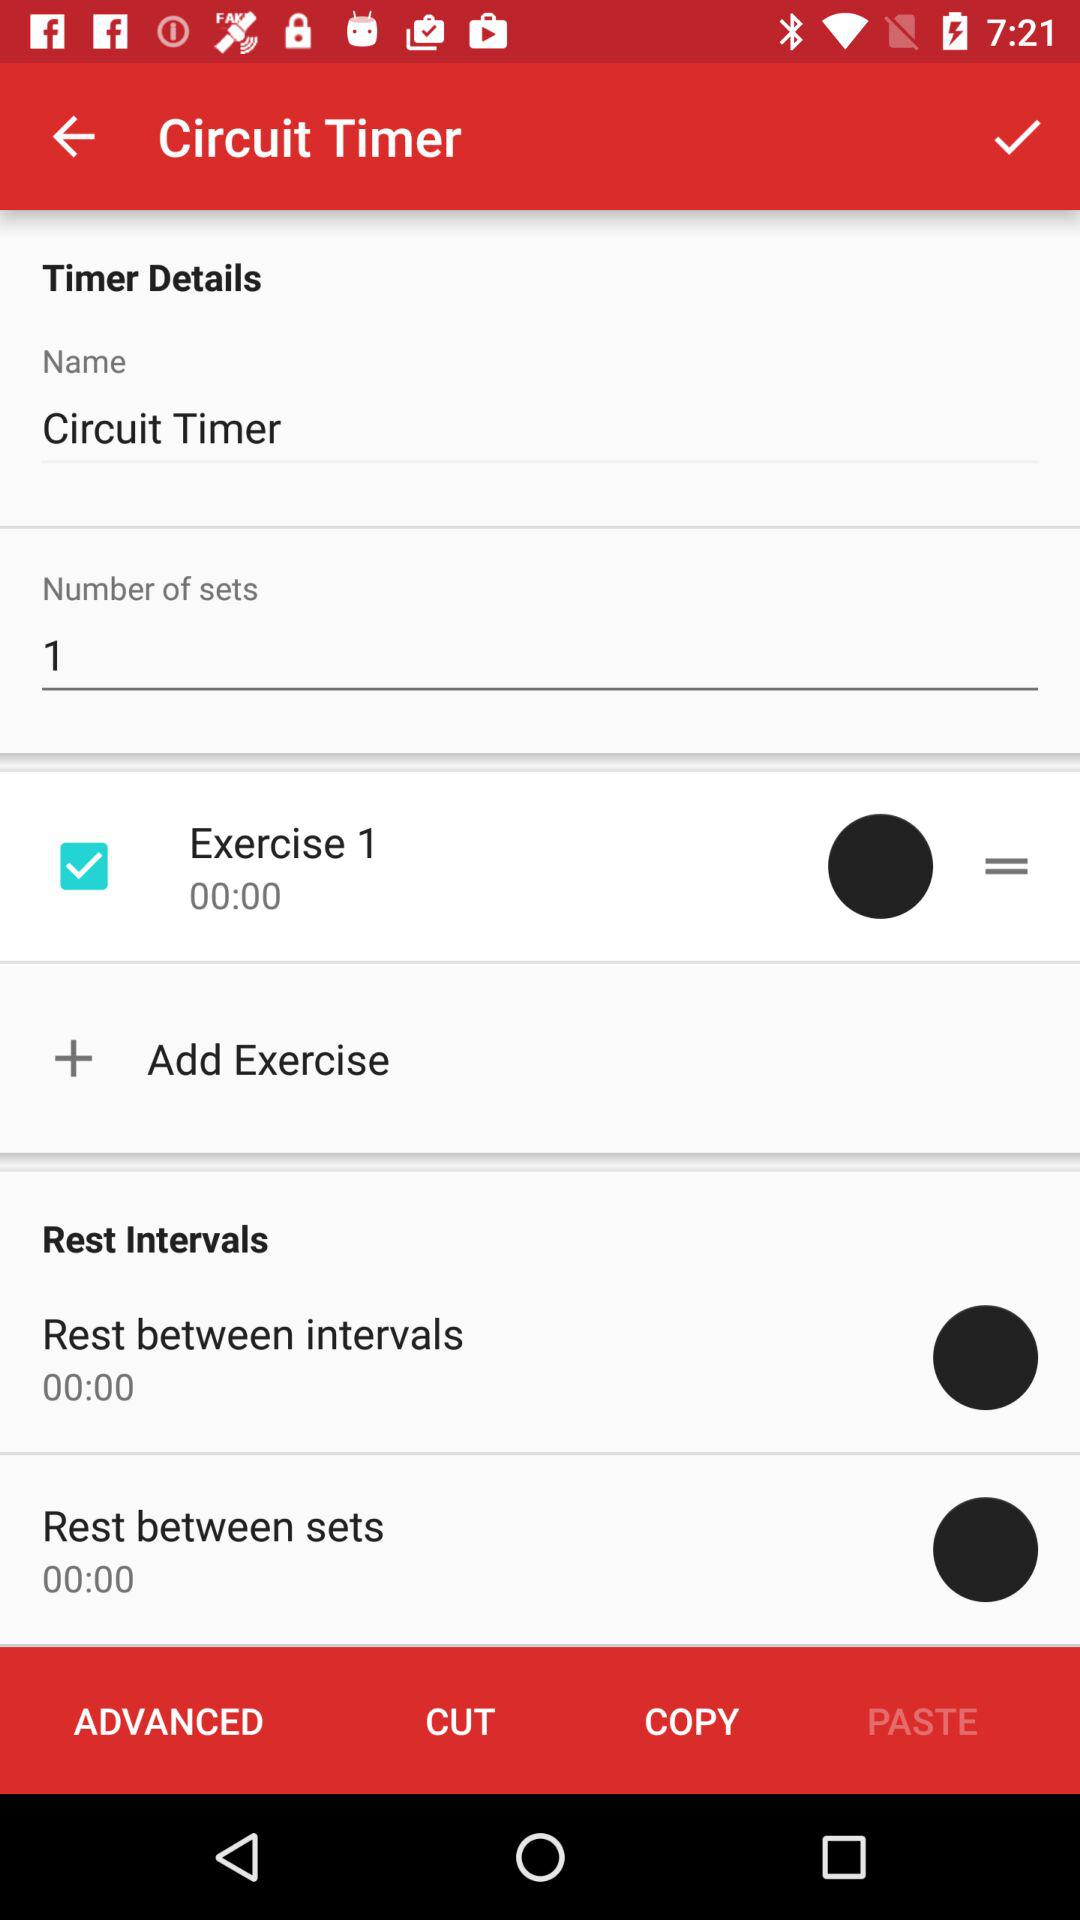What is the status of "Exercise 1"? The status is "on". 